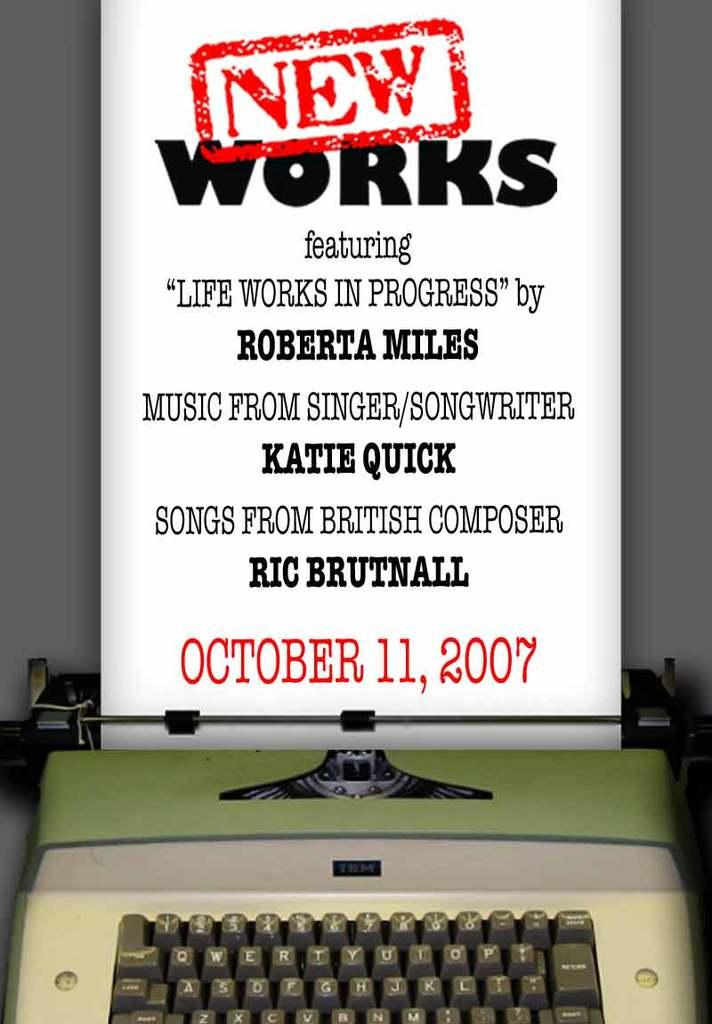<image>
Summarize the visual content of the image. a white paper that has new works at the top 